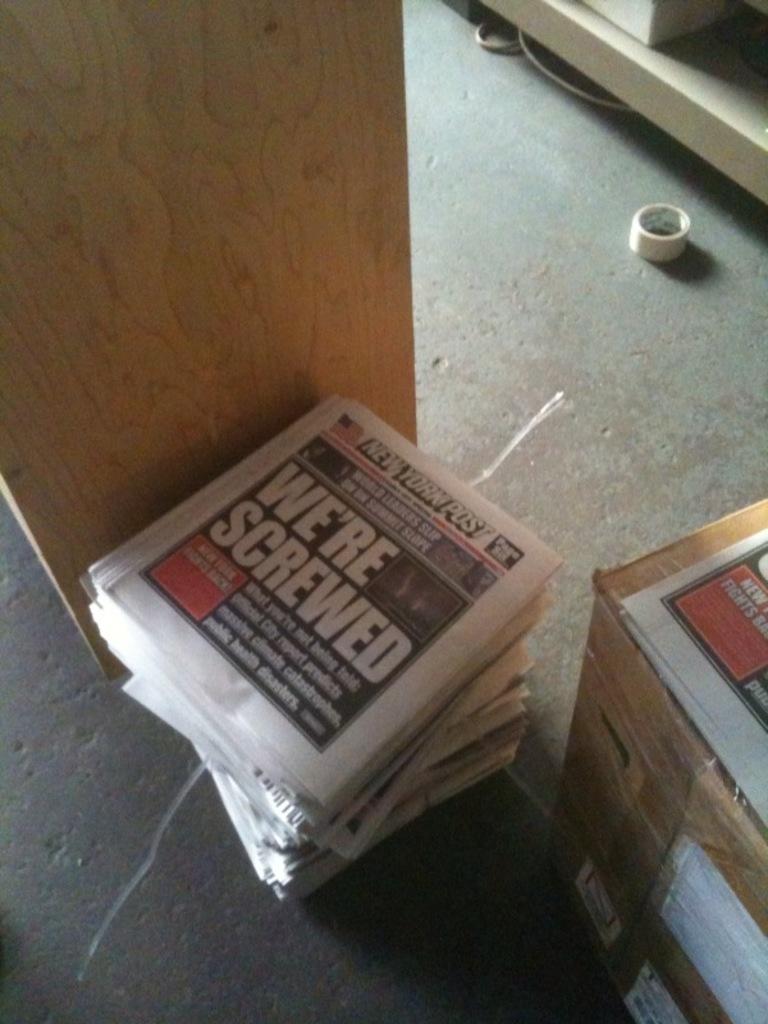What is the name of this paper?
Your response must be concise. New york post. 